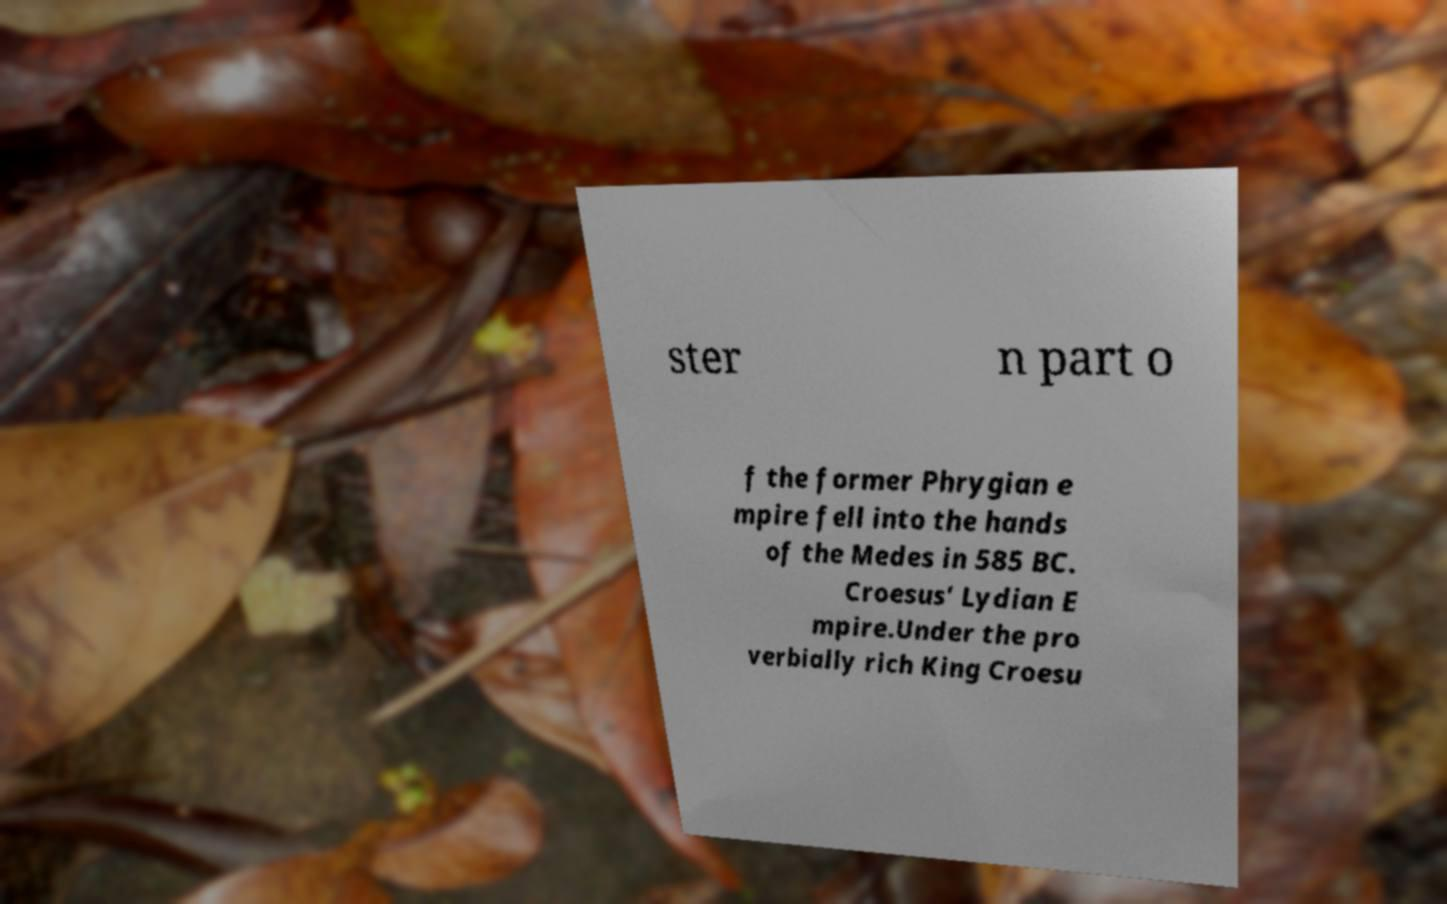What messages or text are displayed in this image? I need them in a readable, typed format. ster n part o f the former Phrygian e mpire fell into the hands of the Medes in 585 BC. Croesus' Lydian E mpire.Under the pro verbially rich King Croesu 